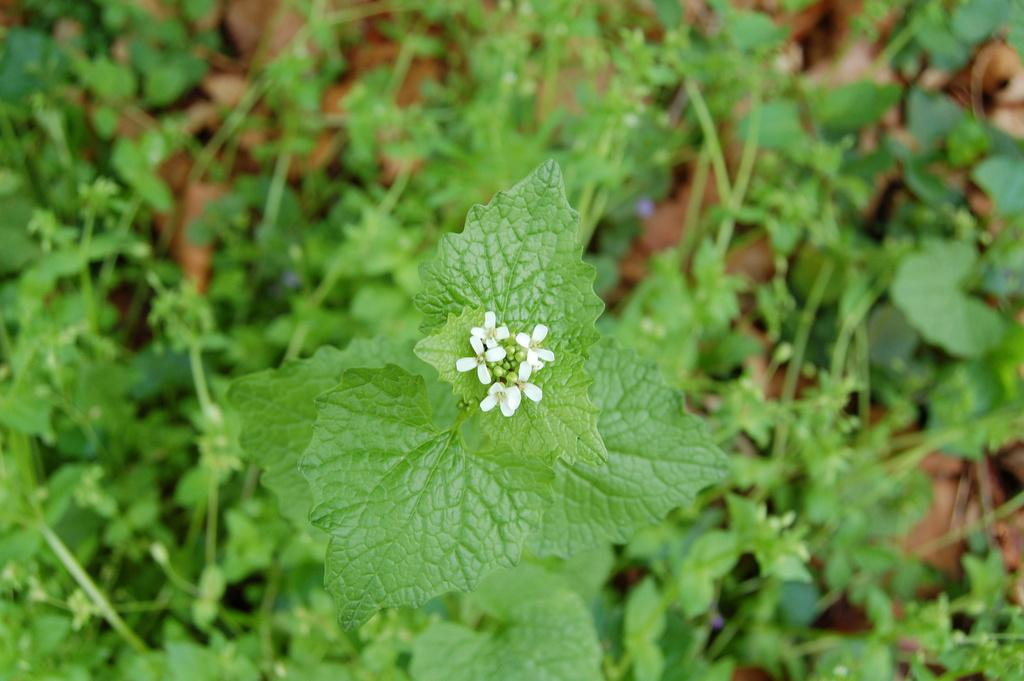What type of living organisms can be seen in the image? There are creeps in the image. What other elements can be seen in the image besides the creeps? There are flowers in the image. What holiday is being celebrated in the image? There is no indication of a holiday being celebrated in the image. How many fingers can be seen in the image? There is no mention of fingers in the image, as it only features creeps and flowers. 